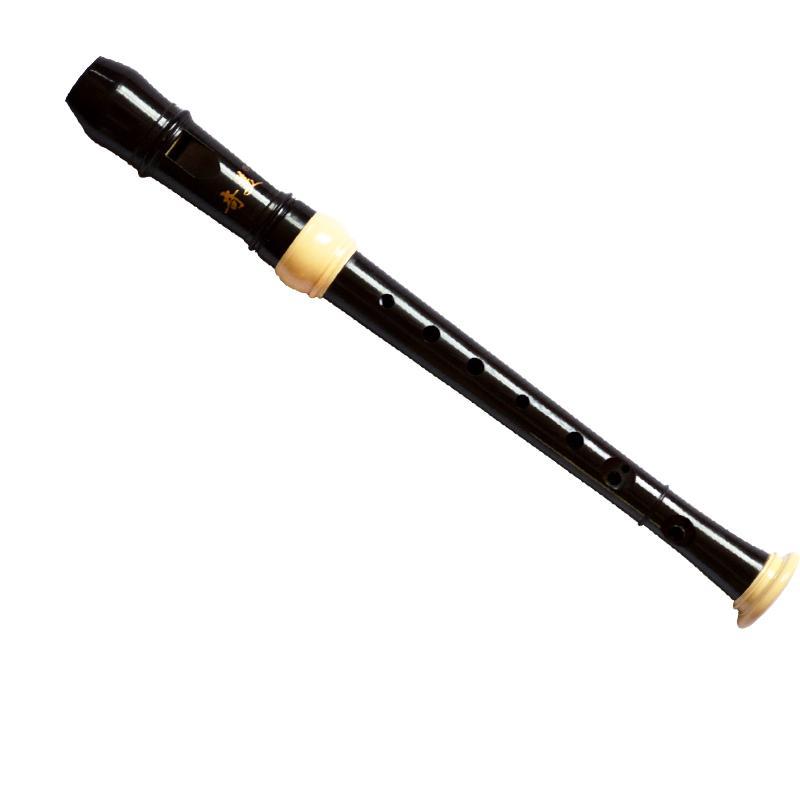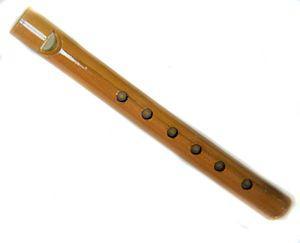The first image is the image on the left, the second image is the image on the right. Assess this claim about the two images: "The left and right images do not contain the same number of items, but the combined images include at least four items of the same color.". Correct or not? Answer yes or no. No. The first image is the image on the left, the second image is the image on the right. Examine the images to the left and right. Is the description "There are two musical instruments." accurate? Answer yes or no. Yes. 